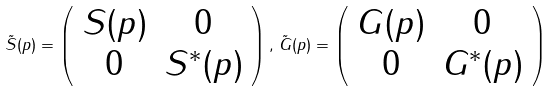<formula> <loc_0><loc_0><loc_500><loc_500>\tilde { S } ( p ) = \left ( \begin{array} { c c } S ( p ) & 0 \\ 0 & S ^ { * } ( p ) \\ \end{array} \right ) , \, \tilde { G } ( p ) = \left ( \begin{array} { c c } G ( p ) & 0 \\ 0 & G ^ { * } ( p ) \\ \end{array} \right )</formula> 